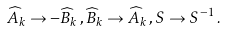<formula> <loc_0><loc_0><loc_500><loc_500>\widehat { A } _ { k } \rightarrow - \widehat { B } _ { k } \, , \widehat { B } _ { k } \rightarrow \widehat { A } _ { k } \, , S \rightarrow S ^ { - 1 } \, .</formula> 